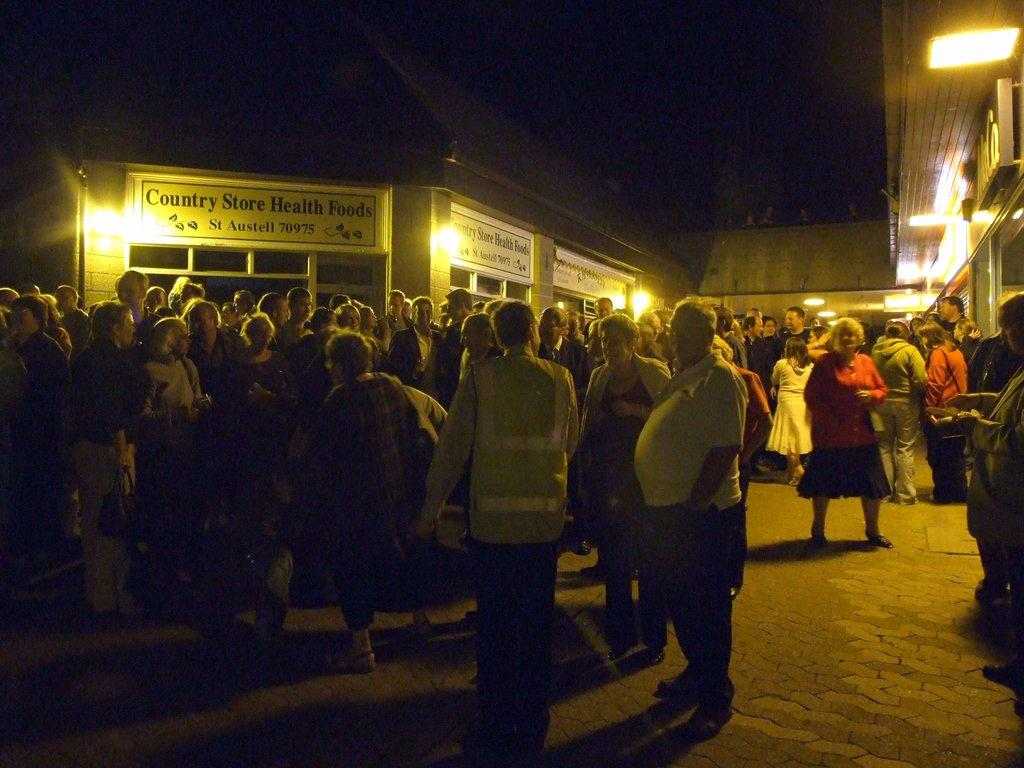What type of structures can be seen in the image? There are houses in the image. What else is present in the image besides the houses? There are boards with text and lights on the ceiling in the image. Are there any people visible in the image? Yes, there are people standing in the image. What type of produce is being sold by the people in the image? There is no produce present in the image; the people are standing without any items for sale. How many clocks can be seen hanging on the walls in the image? There are no clocks visible in the image; only lights on the ceiling are mentioned. 